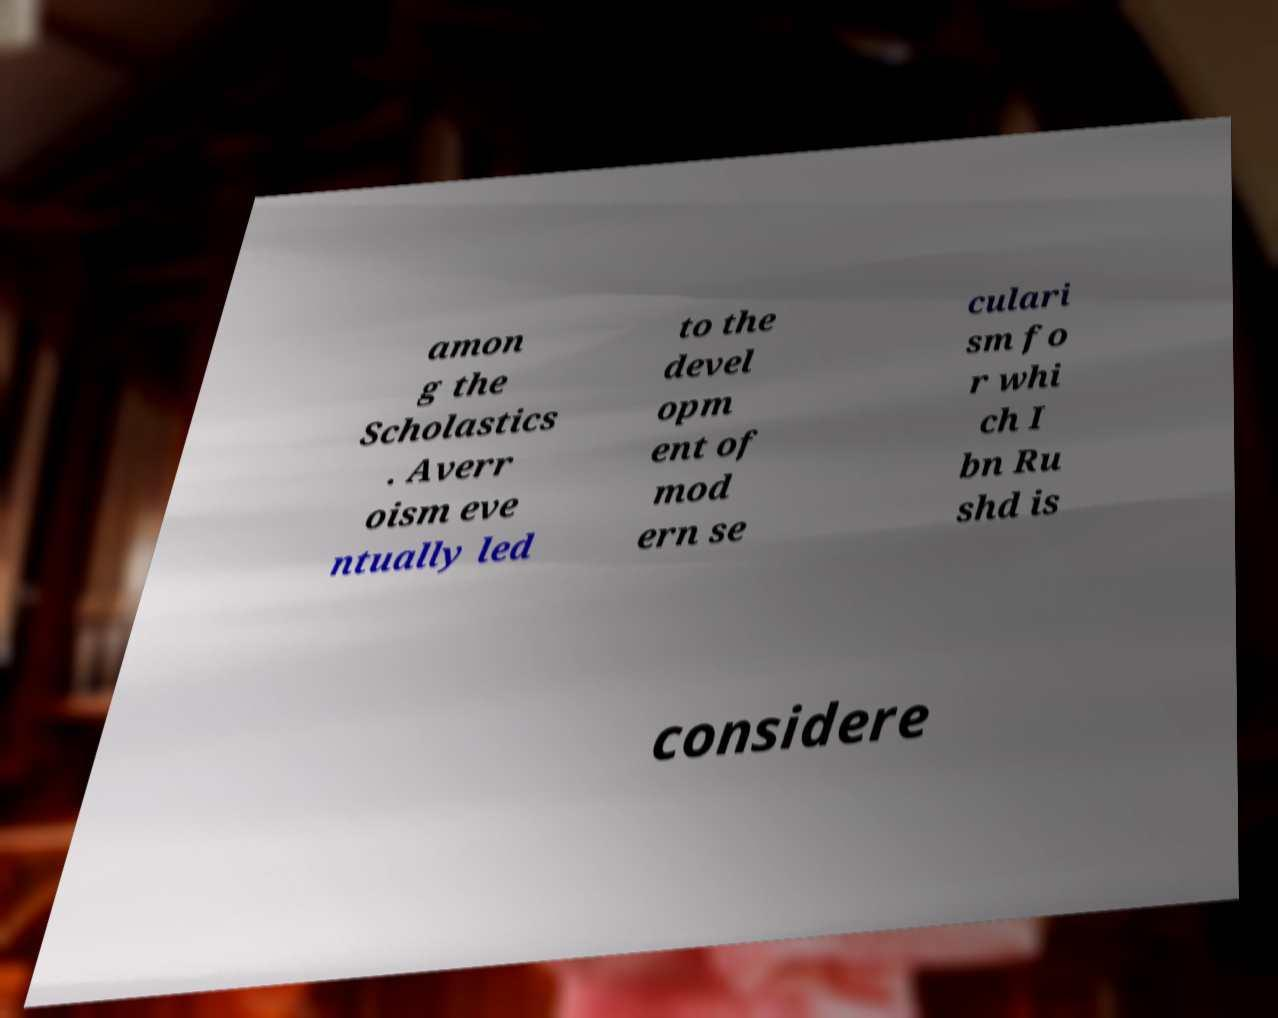Could you assist in decoding the text presented in this image and type it out clearly? amon g the Scholastics . Averr oism eve ntually led to the devel opm ent of mod ern se culari sm fo r whi ch I bn Ru shd is considere 